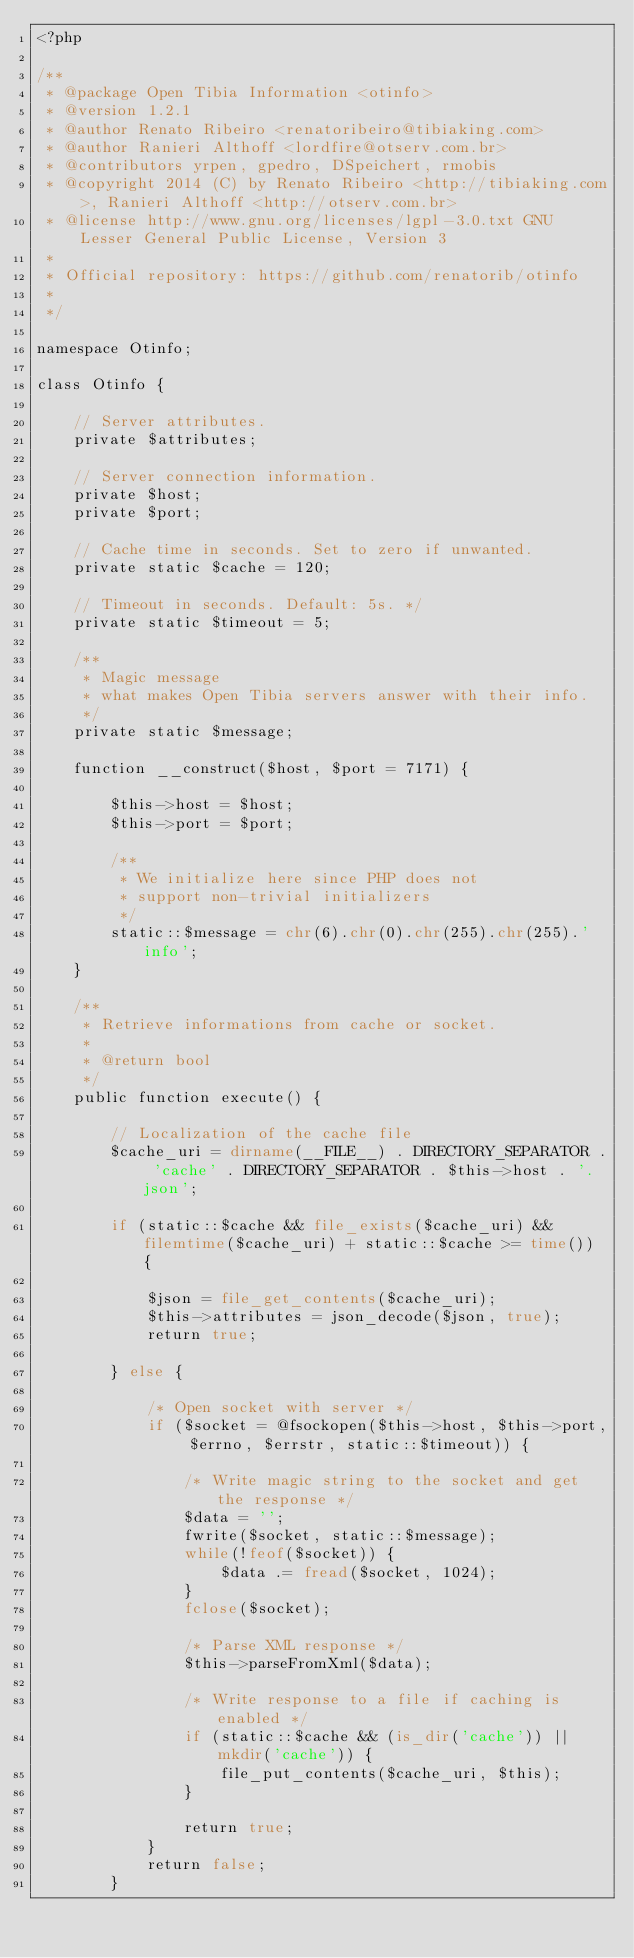<code> <loc_0><loc_0><loc_500><loc_500><_PHP_><?php

/**
 * @package Open Tibia Information <otinfo>
 * @version 1.2.1
 * @author Renato Ribeiro <renatoribeiro@tibiaking.com>
 * @author Ranieri Althoff <lordfire@otserv.com.br>
 * @contributors yrpen, gpedro, DSpeichert, rmobis
 * @copyright 2014 (C) by Renato Ribeiro <http://tibiaking.com>, Ranieri Althoff <http://otserv.com.br>
 * @license http://www.gnu.org/licenses/lgpl-3.0.txt GNU Lesser General Public License, Version 3
 * 
 * Official repository: https://github.com/renatorib/otinfo
 *
 */

namespace Otinfo;

class Otinfo {

    // Server attributes.
    private $attributes;

    // Server connection information.
    private $host;
    private $port;

    // Cache time in seconds. Set to zero if unwanted.
    private static $cache = 120;

    // Timeout in seconds. Default: 5s. */
    private static $timeout = 5;

    /** 
     * Magic message
     * what makes Open Tibia servers answer with their info. 
     */
    private static $message;

    function __construct($host, $port = 7171) {

        $this->host = $host;
        $this->port = $port;

        /**
         * We initialize here since PHP does not 
         * support non-trivial initializers 
         */
        static::$message = chr(6).chr(0).chr(255).chr(255).'info';
    }

    /**
     * Retrieve informations from cache or socket.
     *
     * @return bool
     */
    public function execute() {

        // Localization of the cache file
        $cache_uri = dirname(__FILE__) . DIRECTORY_SEPARATOR . 'cache' . DIRECTORY_SEPARATOR . $this->host . '.json';

        if (static::$cache && file_exists($cache_uri) && filemtime($cache_uri) + static::$cache >= time()) {

            $json = file_get_contents($cache_uri);
            $this->attributes = json_decode($json, true);
            return true;

        } else {

            /* Open socket with server */
            if ($socket = @fsockopen($this->host, $this->port, $errno, $errstr, static::$timeout)) {

                /* Write magic string to the socket and get the response */
                $data = '';
                fwrite($socket, static::$message);
                while(!feof($socket)) {
                    $data .= fread($socket, 1024);
                }
                fclose($socket);

                /* Parse XML response */
                $this->parseFromXml($data);

                /* Write response to a file if caching is enabled */
                if (static::$cache && (is_dir('cache')) || mkdir('cache')) {
                    file_put_contents($cache_uri, $this);
                }

                return true;
            }
            return false;
        }</code> 